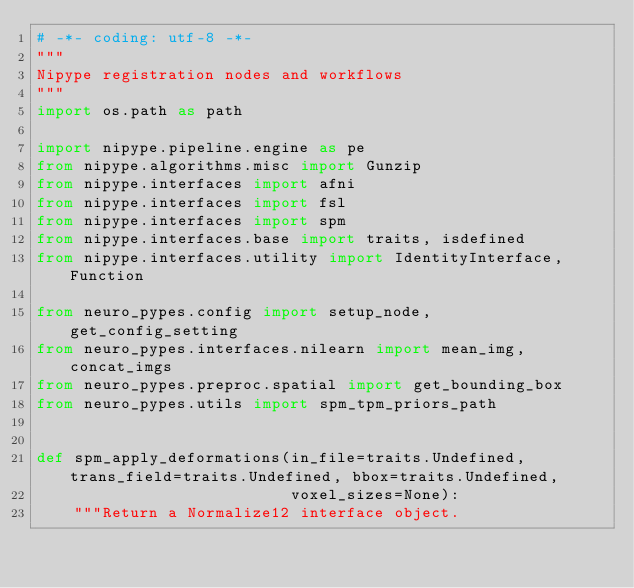<code> <loc_0><loc_0><loc_500><loc_500><_Python_># -*- coding: utf-8 -*-
"""
Nipype registration nodes and workflows
"""
import os.path as path

import nipype.pipeline.engine as pe
from nipype.algorithms.misc import Gunzip
from nipype.interfaces import afni
from nipype.interfaces import fsl
from nipype.interfaces import spm
from nipype.interfaces.base import traits, isdefined
from nipype.interfaces.utility import IdentityInterface, Function

from neuro_pypes.config import setup_node, get_config_setting
from neuro_pypes.interfaces.nilearn import mean_img, concat_imgs
from neuro_pypes.preproc.spatial import get_bounding_box
from neuro_pypes.utils import spm_tpm_priors_path


def spm_apply_deformations(in_file=traits.Undefined, trans_field=traits.Undefined, bbox=traits.Undefined,
                           voxel_sizes=None):
    """Return a Normalize12 interface object.</code> 